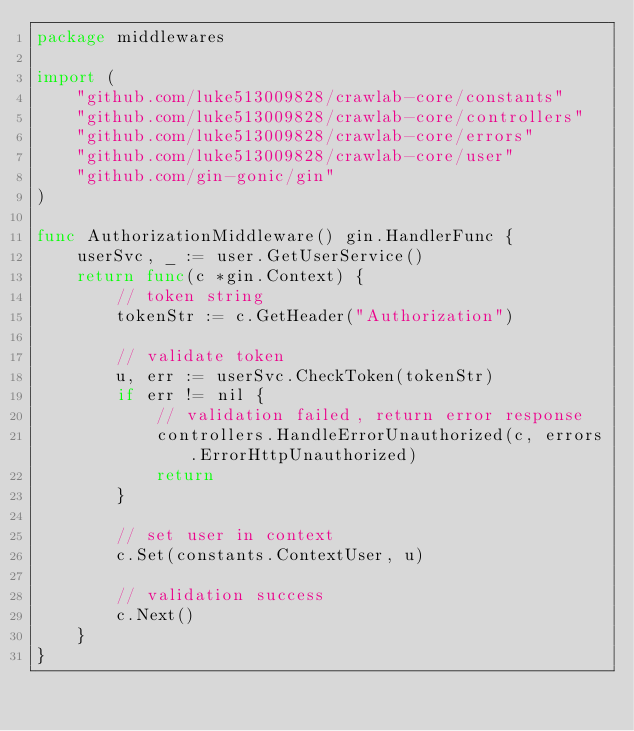Convert code to text. <code><loc_0><loc_0><loc_500><loc_500><_Go_>package middlewares

import (
	"github.com/luke513009828/crawlab-core/constants"
	"github.com/luke513009828/crawlab-core/controllers"
	"github.com/luke513009828/crawlab-core/errors"
	"github.com/luke513009828/crawlab-core/user"
	"github.com/gin-gonic/gin"
)

func AuthorizationMiddleware() gin.HandlerFunc {
	userSvc, _ := user.GetUserService()
	return func(c *gin.Context) {
		// token string
		tokenStr := c.GetHeader("Authorization")

		// validate token
		u, err := userSvc.CheckToken(tokenStr)
		if err != nil {
			// validation failed, return error response
			controllers.HandleErrorUnauthorized(c, errors.ErrorHttpUnauthorized)
			return
		}

		// set user in context
		c.Set(constants.ContextUser, u)

		// validation success
		c.Next()
	}
}
</code> 